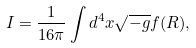<formula> <loc_0><loc_0><loc_500><loc_500>I = \frac { 1 } { 1 6 \pi } \int d ^ { 4 } x \sqrt { - g } f ( R ) ,</formula> 